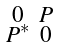Convert formula to latex. <formula><loc_0><loc_0><loc_500><loc_500>\begin{smallmatrix} 0 & P \\ P ^ { * } & 0 \end{smallmatrix}</formula> 